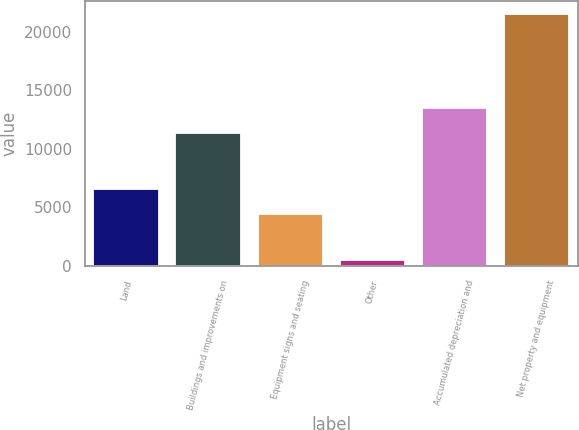Convert chart. <chart><loc_0><loc_0><loc_500><loc_500><bar_chart><fcel>Land<fcel>Buildings and improvements on<fcel>Equipment signs and seating<fcel>Other<fcel>Accumulated depreciation and<fcel>Net property and equipment<nl><fcel>6525.81<fcel>11347.9<fcel>4422.9<fcel>502.4<fcel>13450.8<fcel>21531.5<nl></chart> 